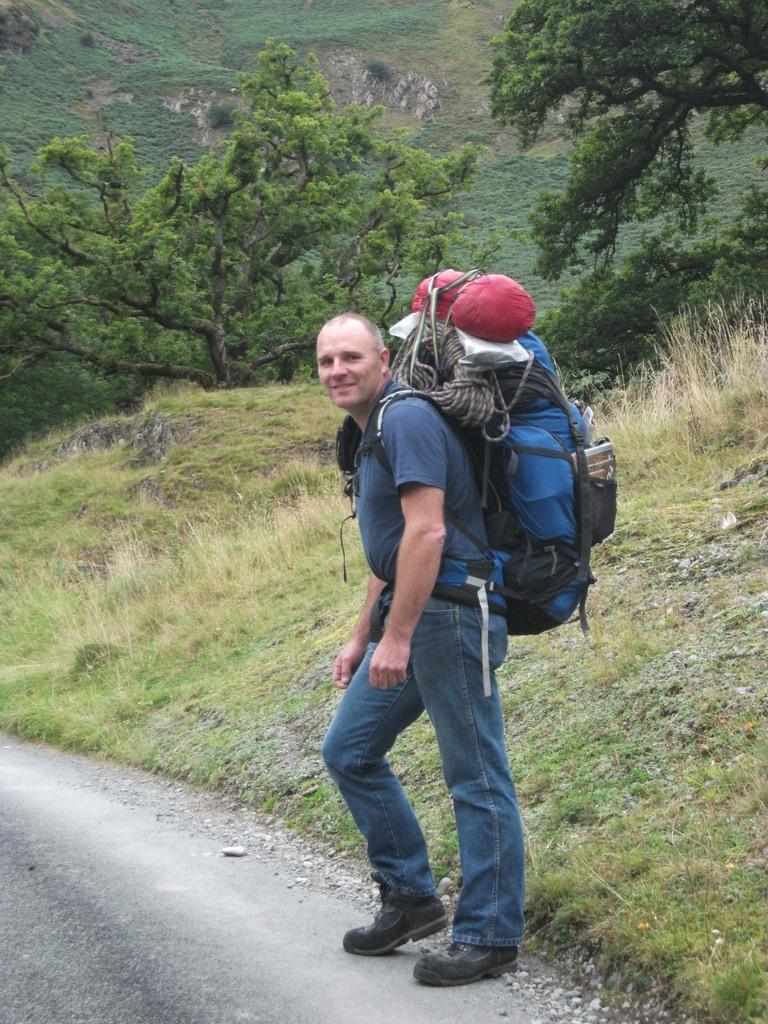What is the person in the image doing? The person is standing on a road. What is the person carrying on his shoulders? The person is wearing a travel bag on his shoulders. What can be seen beside the person? There are trees beside the person. What type of landscape is visible in the image? There are mountains visible in the image. What type of vegetation is present in the image? There is grass in the image. What type of kettle is visible in the image? There is no kettle present in the image. Who is the owner of the mountains in the image? The concept of ownership of natural landmarks like mountains is not applicable in this context, as they are not owned by any individual or entity. 